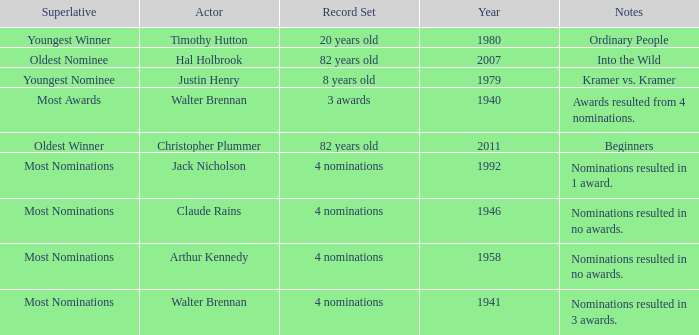What record was set by walter brennan before 1941? 3 awards. 